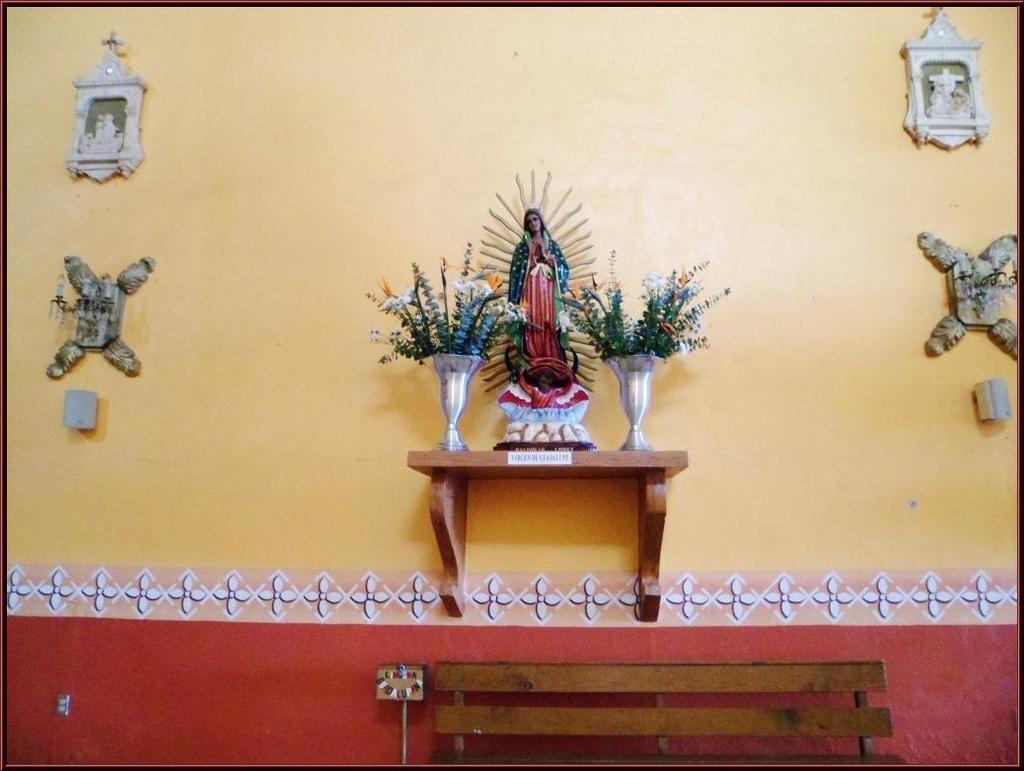How would you summarize this image in a sentence or two? In this picture we can see bench, behind there is a wall on which we can see some sculpture along flower pots. 